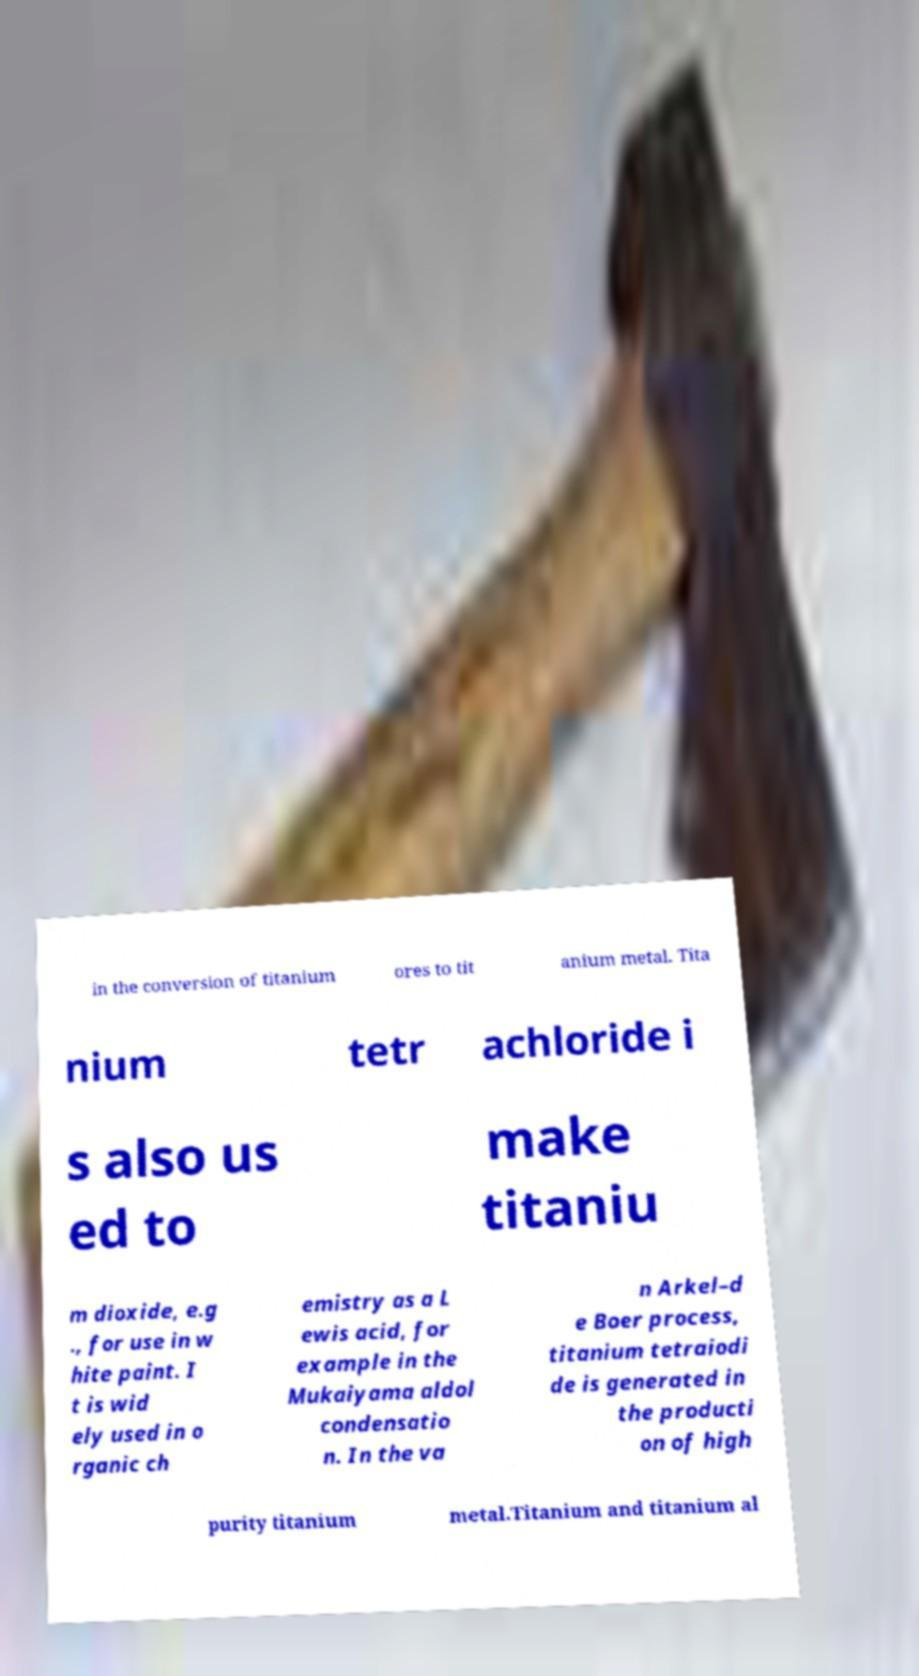Please identify and transcribe the text found in this image. in the conversion of titanium ores to tit anium metal. Tita nium tetr achloride i s also us ed to make titaniu m dioxide, e.g ., for use in w hite paint. I t is wid ely used in o rganic ch emistry as a L ewis acid, for example in the Mukaiyama aldol condensatio n. In the va n Arkel–d e Boer process, titanium tetraiodi de is generated in the producti on of high purity titanium metal.Titanium and titanium al 